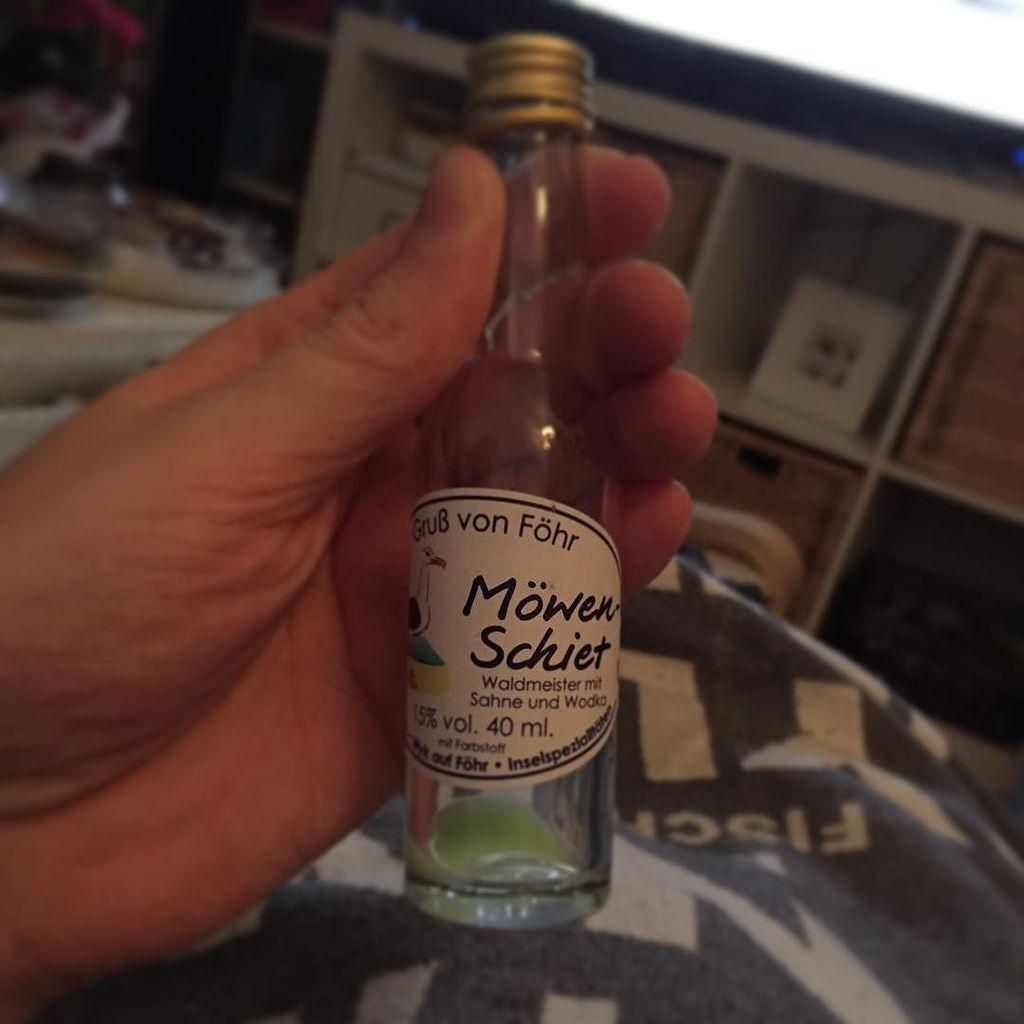<image>
Write a terse but informative summary of the picture. A forty milliliter bottle Mowen Schiet alcohol with a seagull on the label. 